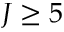<formula> <loc_0><loc_0><loc_500><loc_500>J \geq 5</formula> 